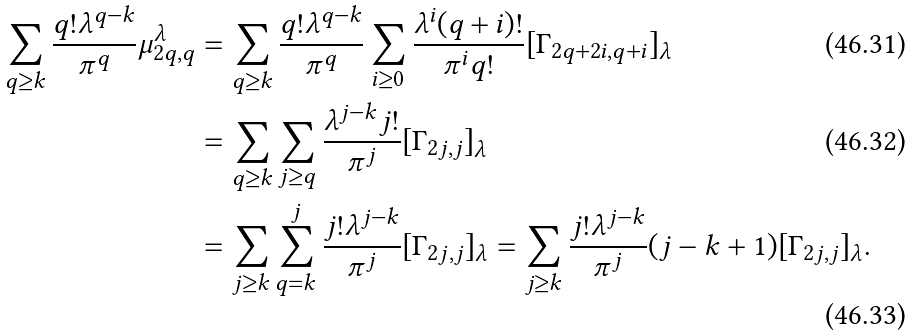Convert formula to latex. <formula><loc_0><loc_0><loc_500><loc_500>\sum _ { q \geq k } \frac { q ! \lambda ^ { q - k } } { \pi ^ { q } } \mu _ { 2 q , q } ^ { \lambda } & = \sum _ { q \geq k } \frac { q ! \lambda ^ { q - k } } { \pi ^ { q } } \sum _ { i \geq 0 } \frac { \lambda ^ { i } ( q + i ) ! } { \pi ^ { i } q ! } [ \Gamma _ { 2 q + 2 i , q + i } ] _ { \lambda } \\ & = \sum _ { q \geq k } \sum _ { j \geq q } \frac { \lambda ^ { j - k } j ! } { \pi ^ { j } } [ \Gamma _ { 2 j , j } ] _ { \lambda } \\ & = \sum _ { j \geq k } \sum _ { q = k } ^ { j } \frac { j ! \lambda ^ { j - k } } { \pi ^ { j } } [ \Gamma _ { 2 j , j } ] _ { \lambda } = \sum _ { j \geq k } \frac { j ! \lambda ^ { j - k } } { \pi ^ { j } } ( j - k + 1 ) [ \Gamma _ { 2 j , j } ] _ { \lambda } .</formula> 